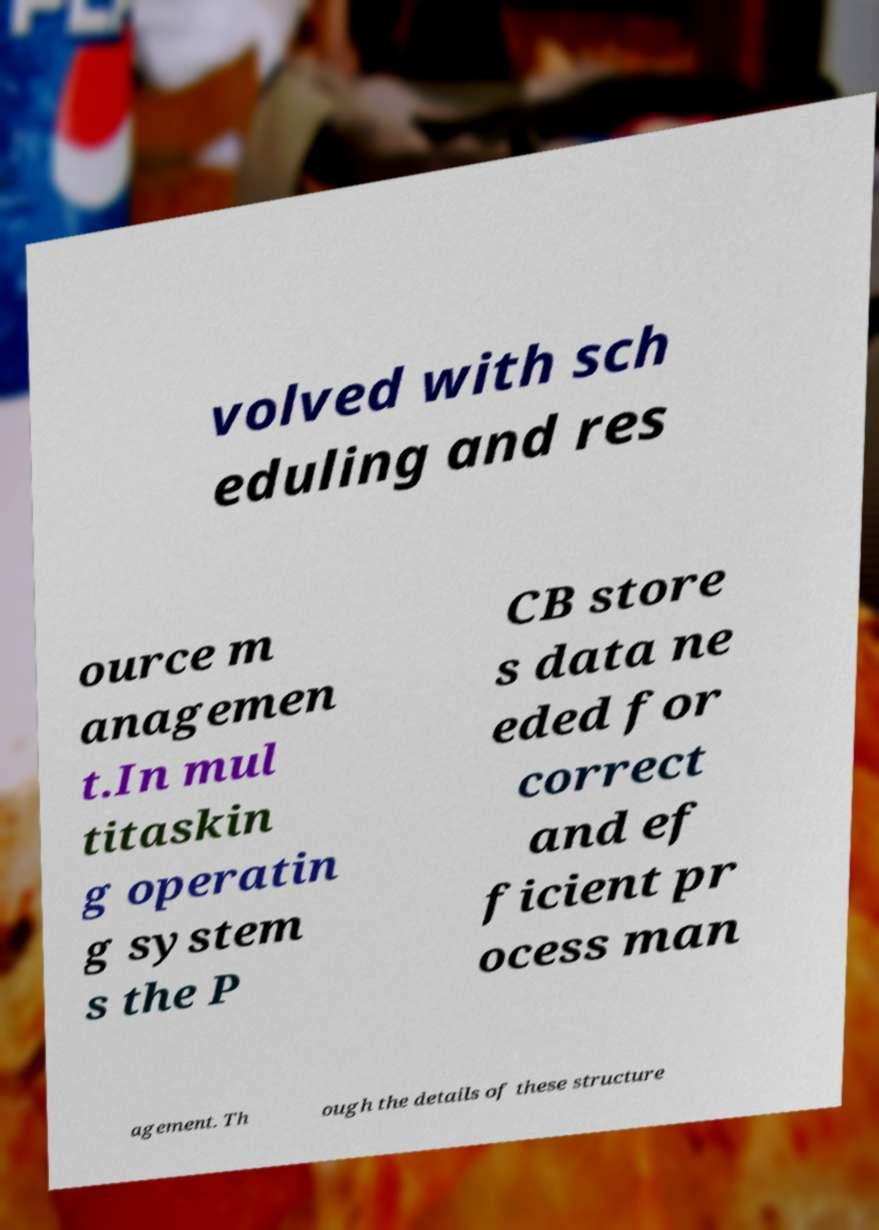I need the written content from this picture converted into text. Can you do that? volved with sch eduling and res ource m anagemen t.In mul titaskin g operatin g system s the P CB store s data ne eded for correct and ef ficient pr ocess man agement. Th ough the details of these structure 